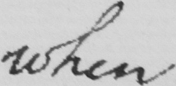Please transcribe the handwritten text in this image. when 